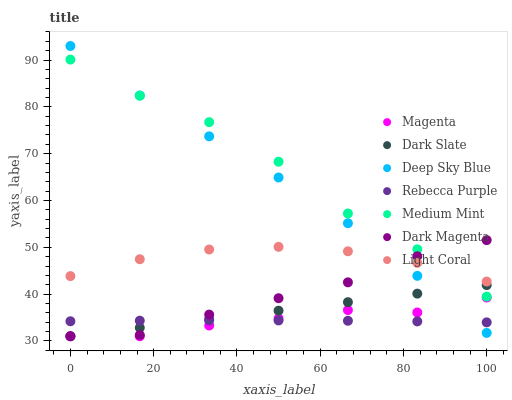Does Rebecca Purple have the minimum area under the curve?
Answer yes or no. Yes. Does Medium Mint have the maximum area under the curve?
Answer yes or no. Yes. Does Dark Magenta have the minimum area under the curve?
Answer yes or no. No. Does Dark Magenta have the maximum area under the curve?
Answer yes or no. No. Is Dark Slate the smoothest?
Answer yes or no. Yes. Is Medium Mint the roughest?
Answer yes or no. Yes. Is Dark Magenta the smoothest?
Answer yes or no. No. Is Dark Magenta the roughest?
Answer yes or no. No. Does Dark Magenta have the lowest value?
Answer yes or no. Yes. Does Light Coral have the lowest value?
Answer yes or no. No. Does Deep Sky Blue have the highest value?
Answer yes or no. Yes. Does Dark Magenta have the highest value?
Answer yes or no. No. Is Magenta less than Medium Mint?
Answer yes or no. Yes. Is Light Coral greater than Dark Slate?
Answer yes or no. Yes. Does Dark Magenta intersect Rebecca Purple?
Answer yes or no. Yes. Is Dark Magenta less than Rebecca Purple?
Answer yes or no. No. Is Dark Magenta greater than Rebecca Purple?
Answer yes or no. No. Does Magenta intersect Medium Mint?
Answer yes or no. No. 